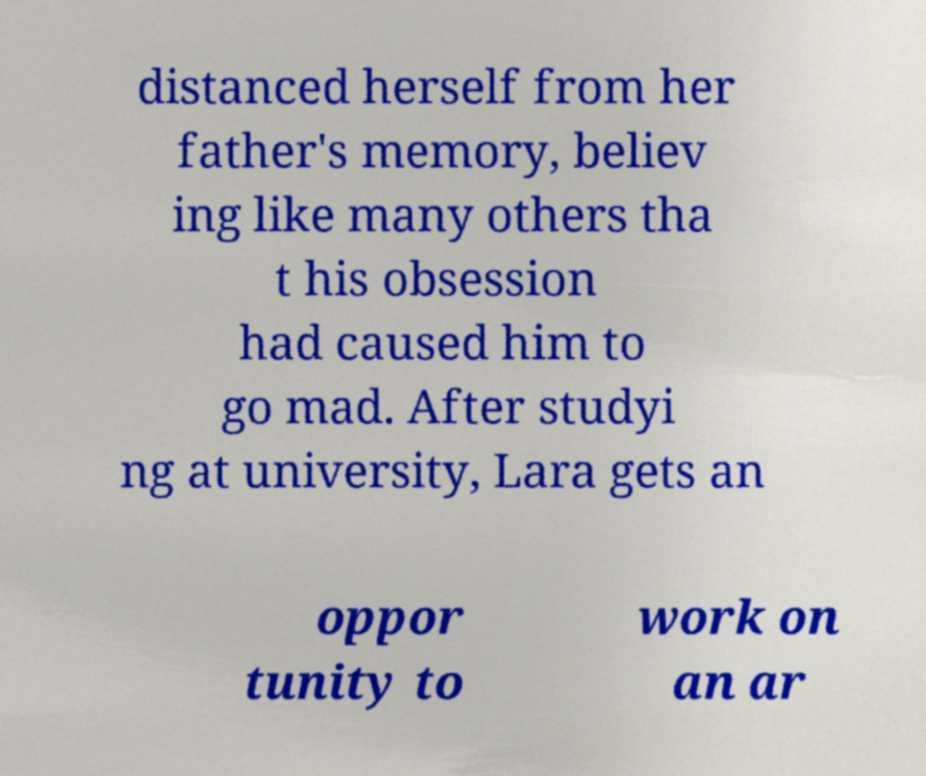Could you extract and type out the text from this image? distanced herself from her father's memory, believ ing like many others tha t his obsession had caused him to go mad. After studyi ng at university, Lara gets an oppor tunity to work on an ar 